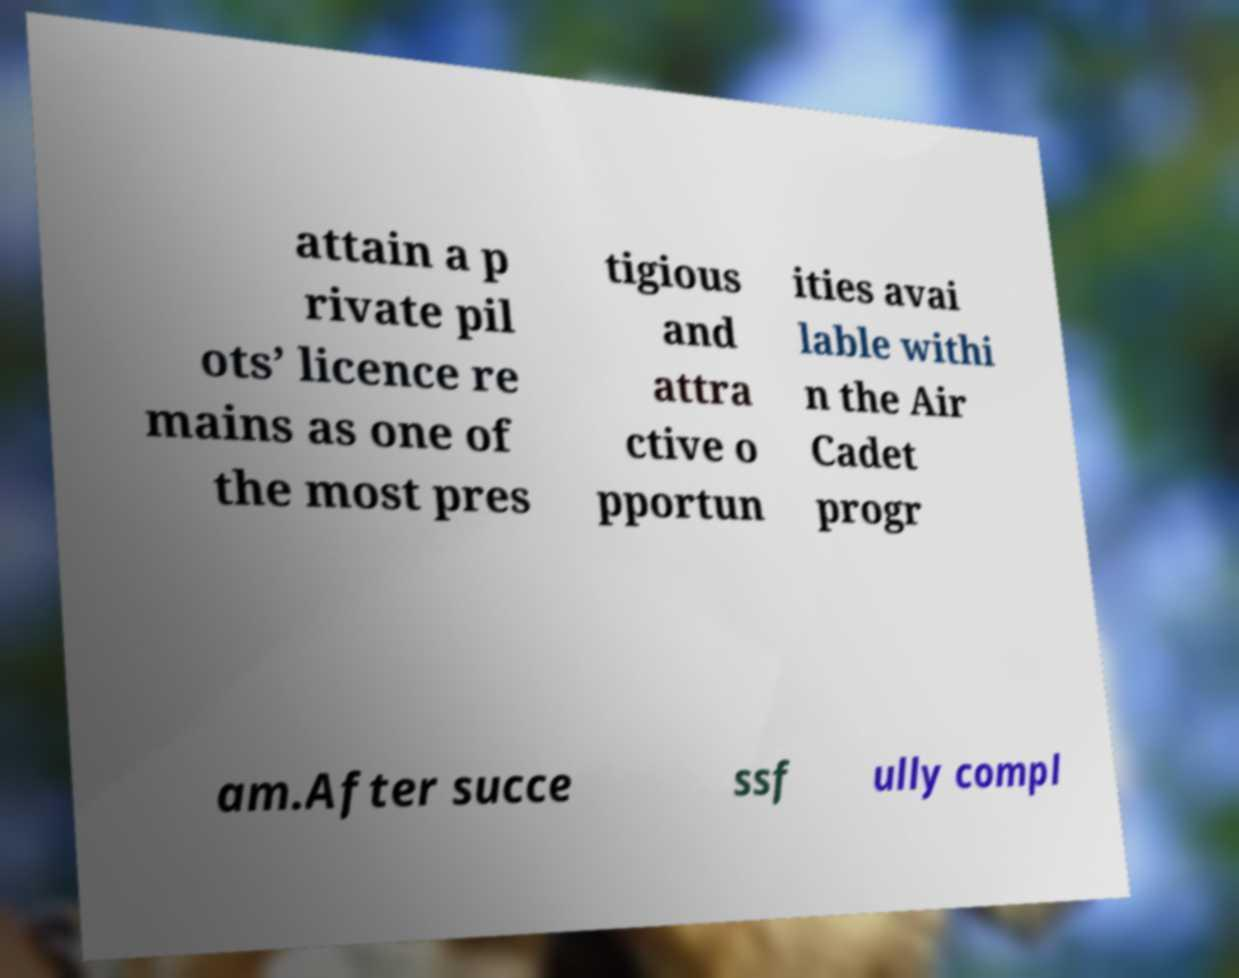Can you accurately transcribe the text from the provided image for me? attain a p rivate pil ots’ licence re mains as one of the most pres tigious and attra ctive o pportun ities avai lable withi n the Air Cadet progr am.After succe ssf ully compl 